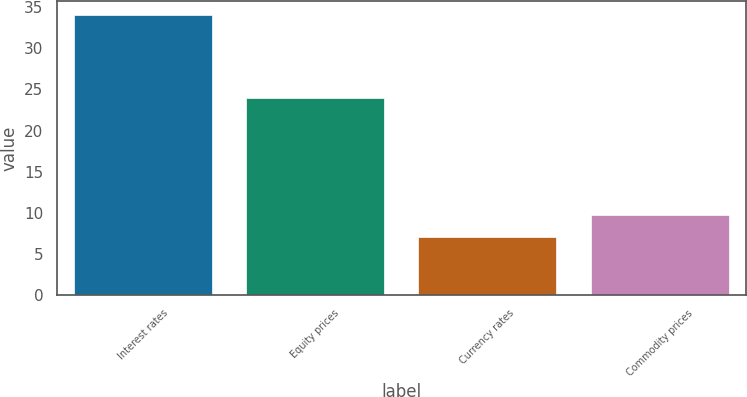Convert chart to OTSL. <chart><loc_0><loc_0><loc_500><loc_500><bar_chart><fcel>Interest rates<fcel>Equity prices<fcel>Currency rates<fcel>Commodity prices<nl><fcel>34<fcel>24<fcel>7<fcel>9.7<nl></chart> 